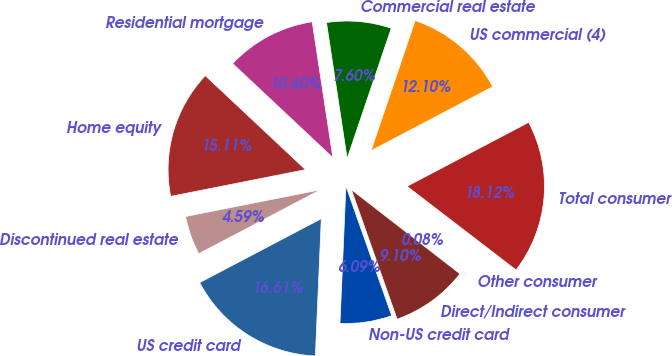Convert chart. <chart><loc_0><loc_0><loc_500><loc_500><pie_chart><fcel>Residential mortgage<fcel>Home equity<fcel>Discontinued real estate<fcel>US credit card<fcel>Non-US credit card<fcel>Direct/Indirect consumer<fcel>Other consumer<fcel>Total consumer<fcel>US commercial (4)<fcel>Commercial real estate<nl><fcel>10.6%<fcel>15.11%<fcel>4.59%<fcel>16.61%<fcel>6.09%<fcel>9.1%<fcel>0.08%<fcel>18.12%<fcel>12.1%<fcel>7.6%<nl></chart> 